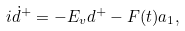Convert formula to latex. <formula><loc_0><loc_0><loc_500><loc_500>i \dot { d } ^ { + } = - E _ { v } d ^ { + } - F ( t ) a _ { 1 } ,</formula> 